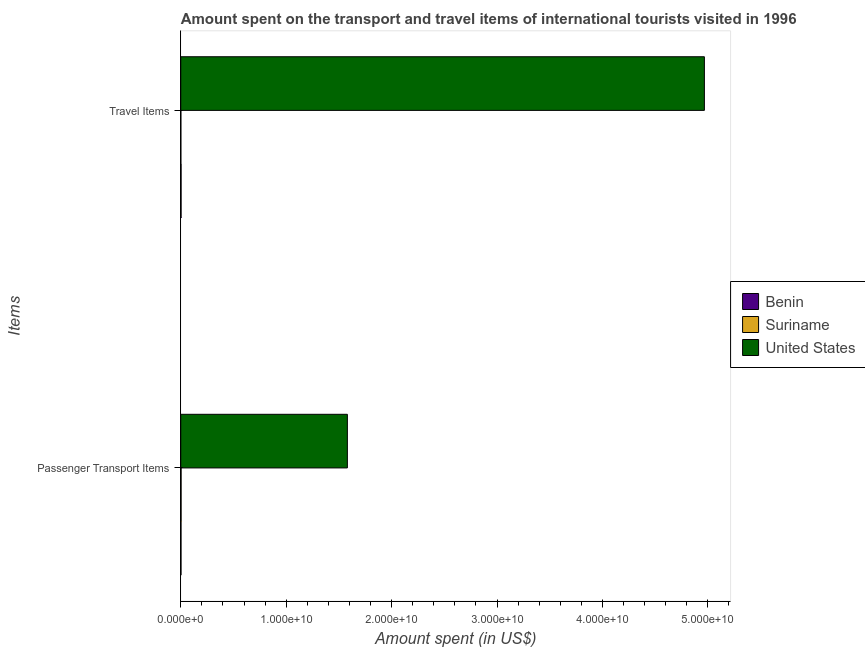How many different coloured bars are there?
Provide a short and direct response. 3. How many bars are there on the 1st tick from the bottom?
Offer a very short reply. 3. What is the label of the 2nd group of bars from the top?
Ensure brevity in your answer.  Passenger Transport Items. What is the amount spent in travel items in Suriname?
Offer a very short reply. 8.00e+06. Across all countries, what is the maximum amount spent on passenger transport items?
Your response must be concise. 1.58e+1. Across all countries, what is the minimum amount spent in travel items?
Your answer should be very brief. 8.00e+06. In which country was the amount spent in travel items minimum?
Provide a short and direct response. Suriname. What is the total amount spent on passenger transport items in the graph?
Make the answer very short. 1.59e+1. What is the difference between the amount spent in travel items in Suriname and that in Benin?
Your response must be concise. -2.10e+07. What is the difference between the amount spent on passenger transport items in United States and the amount spent in travel items in Benin?
Your answer should be very brief. 1.58e+1. What is the average amount spent in travel items per country?
Keep it short and to the point. 1.66e+1. What is the difference between the amount spent in travel items and amount spent on passenger transport items in Benin?
Give a very brief answer. 7.00e+06. What is the ratio of the amount spent in travel items in Benin to that in Suriname?
Offer a terse response. 3.62. What does the 2nd bar from the bottom in Travel Items represents?
Give a very brief answer. Suriname. Are all the bars in the graph horizontal?
Make the answer very short. Yes. Are the values on the major ticks of X-axis written in scientific E-notation?
Your response must be concise. Yes. How are the legend labels stacked?
Make the answer very short. Vertical. What is the title of the graph?
Your answer should be compact. Amount spent on the transport and travel items of international tourists visited in 1996. Does "Korea (Republic)" appear as one of the legend labels in the graph?
Provide a short and direct response. No. What is the label or title of the X-axis?
Your answer should be compact. Amount spent (in US$). What is the label or title of the Y-axis?
Your response must be concise. Items. What is the Amount spent (in US$) of Benin in Passenger Transport Items?
Provide a short and direct response. 2.20e+07. What is the Amount spent (in US$) of Suriname in Passenger Transport Items?
Keep it short and to the point. 3.00e+07. What is the Amount spent (in US$) in United States in Passenger Transport Items?
Provide a short and direct response. 1.58e+1. What is the Amount spent (in US$) of Benin in Travel Items?
Give a very brief answer. 2.90e+07. What is the Amount spent (in US$) in United States in Travel Items?
Offer a very short reply. 4.97e+1. Across all Items, what is the maximum Amount spent (in US$) in Benin?
Give a very brief answer. 2.90e+07. Across all Items, what is the maximum Amount spent (in US$) of Suriname?
Offer a very short reply. 3.00e+07. Across all Items, what is the maximum Amount spent (in US$) in United States?
Give a very brief answer. 4.97e+1. Across all Items, what is the minimum Amount spent (in US$) in Benin?
Provide a succinct answer. 2.20e+07. Across all Items, what is the minimum Amount spent (in US$) of Suriname?
Your answer should be compact. 8.00e+06. Across all Items, what is the minimum Amount spent (in US$) in United States?
Your answer should be compact. 1.58e+1. What is the total Amount spent (in US$) in Benin in the graph?
Keep it short and to the point. 5.10e+07. What is the total Amount spent (in US$) of Suriname in the graph?
Give a very brief answer. 3.80e+07. What is the total Amount spent (in US$) of United States in the graph?
Provide a succinct answer. 6.55e+1. What is the difference between the Amount spent (in US$) of Benin in Passenger Transport Items and that in Travel Items?
Provide a succinct answer. -7.00e+06. What is the difference between the Amount spent (in US$) of Suriname in Passenger Transport Items and that in Travel Items?
Your answer should be compact. 2.20e+07. What is the difference between the Amount spent (in US$) in United States in Passenger Transport Items and that in Travel Items?
Your answer should be very brief. -3.39e+1. What is the difference between the Amount spent (in US$) of Benin in Passenger Transport Items and the Amount spent (in US$) of Suriname in Travel Items?
Keep it short and to the point. 1.40e+07. What is the difference between the Amount spent (in US$) in Benin in Passenger Transport Items and the Amount spent (in US$) in United States in Travel Items?
Your answer should be compact. -4.96e+1. What is the difference between the Amount spent (in US$) in Suriname in Passenger Transport Items and the Amount spent (in US$) in United States in Travel Items?
Your answer should be compact. -4.96e+1. What is the average Amount spent (in US$) in Benin per Items?
Make the answer very short. 2.55e+07. What is the average Amount spent (in US$) in Suriname per Items?
Ensure brevity in your answer.  1.90e+07. What is the average Amount spent (in US$) in United States per Items?
Your answer should be compact. 3.27e+1. What is the difference between the Amount spent (in US$) of Benin and Amount spent (in US$) of Suriname in Passenger Transport Items?
Your answer should be very brief. -8.00e+06. What is the difference between the Amount spent (in US$) of Benin and Amount spent (in US$) of United States in Passenger Transport Items?
Provide a succinct answer. -1.58e+1. What is the difference between the Amount spent (in US$) in Suriname and Amount spent (in US$) in United States in Passenger Transport Items?
Your answer should be compact. -1.58e+1. What is the difference between the Amount spent (in US$) of Benin and Amount spent (in US$) of Suriname in Travel Items?
Your answer should be compact. 2.10e+07. What is the difference between the Amount spent (in US$) of Benin and Amount spent (in US$) of United States in Travel Items?
Your answer should be very brief. -4.96e+1. What is the difference between the Amount spent (in US$) in Suriname and Amount spent (in US$) in United States in Travel Items?
Offer a terse response. -4.97e+1. What is the ratio of the Amount spent (in US$) of Benin in Passenger Transport Items to that in Travel Items?
Provide a succinct answer. 0.76. What is the ratio of the Amount spent (in US$) of Suriname in Passenger Transport Items to that in Travel Items?
Your answer should be very brief. 3.75. What is the ratio of the Amount spent (in US$) in United States in Passenger Transport Items to that in Travel Items?
Provide a short and direct response. 0.32. What is the difference between the highest and the second highest Amount spent (in US$) of Benin?
Your response must be concise. 7.00e+06. What is the difference between the highest and the second highest Amount spent (in US$) of Suriname?
Give a very brief answer. 2.20e+07. What is the difference between the highest and the second highest Amount spent (in US$) of United States?
Offer a terse response. 3.39e+1. What is the difference between the highest and the lowest Amount spent (in US$) in Benin?
Offer a terse response. 7.00e+06. What is the difference between the highest and the lowest Amount spent (in US$) in Suriname?
Offer a very short reply. 2.20e+07. What is the difference between the highest and the lowest Amount spent (in US$) in United States?
Offer a very short reply. 3.39e+1. 